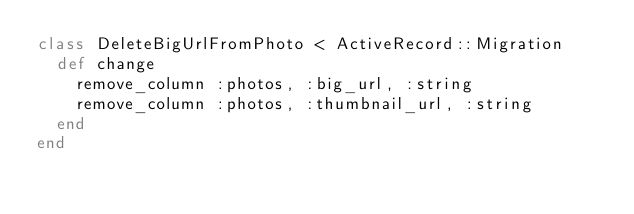<code> <loc_0><loc_0><loc_500><loc_500><_Ruby_>class DeleteBigUrlFromPhoto < ActiveRecord::Migration
  def change
    remove_column :photos, :big_url, :string
    remove_column :photos, :thumbnail_url, :string
  end
end
</code> 